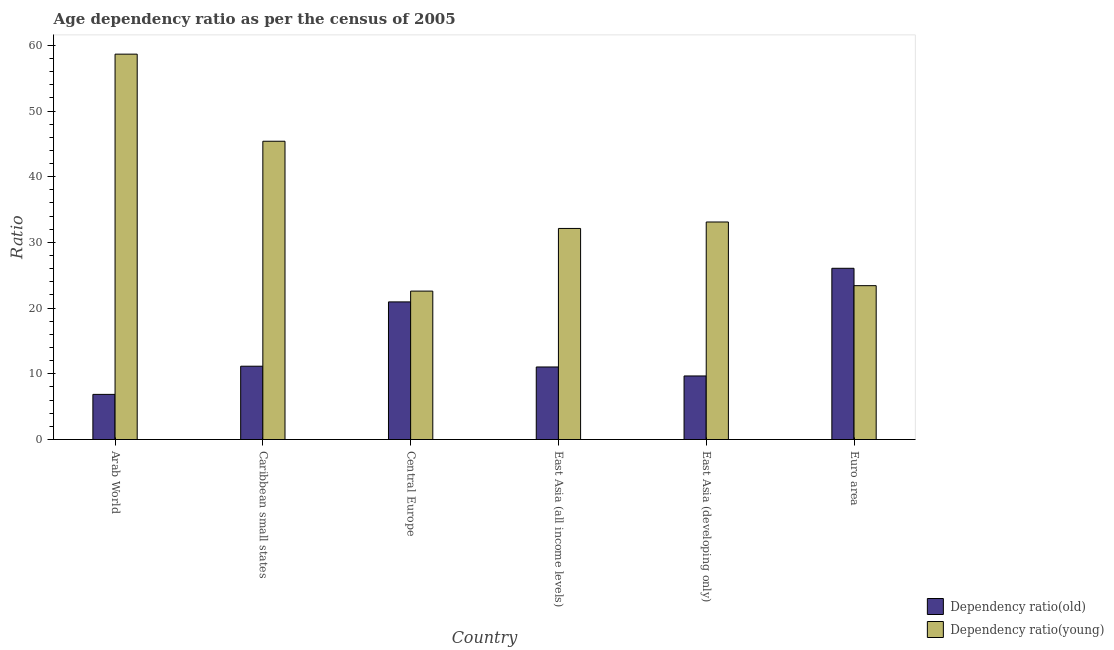Are the number of bars per tick equal to the number of legend labels?
Provide a succinct answer. Yes. How many bars are there on the 5th tick from the right?
Your answer should be compact. 2. What is the label of the 1st group of bars from the left?
Your answer should be compact. Arab World. In how many cases, is the number of bars for a given country not equal to the number of legend labels?
Make the answer very short. 0. What is the age dependency ratio(old) in Arab World?
Ensure brevity in your answer.  6.87. Across all countries, what is the maximum age dependency ratio(old)?
Your response must be concise. 26.06. Across all countries, what is the minimum age dependency ratio(old)?
Make the answer very short. 6.87. In which country was the age dependency ratio(young) maximum?
Offer a very short reply. Arab World. In which country was the age dependency ratio(young) minimum?
Your answer should be very brief. Central Europe. What is the total age dependency ratio(young) in the graph?
Your answer should be compact. 215.29. What is the difference between the age dependency ratio(old) in Caribbean small states and that in East Asia (developing only)?
Ensure brevity in your answer.  1.48. What is the difference between the age dependency ratio(old) in Euro area and the age dependency ratio(young) in Arab World?
Offer a terse response. -32.59. What is the average age dependency ratio(young) per country?
Offer a terse response. 35.88. What is the difference between the age dependency ratio(old) and age dependency ratio(young) in East Asia (developing only)?
Make the answer very short. -23.43. In how many countries, is the age dependency ratio(old) greater than 38 ?
Provide a succinct answer. 0. What is the ratio of the age dependency ratio(old) in Central Europe to that in East Asia (all income levels)?
Make the answer very short. 1.9. Is the age dependency ratio(young) in Caribbean small states less than that in East Asia (developing only)?
Offer a terse response. No. Is the difference between the age dependency ratio(young) in Arab World and Caribbean small states greater than the difference between the age dependency ratio(old) in Arab World and Caribbean small states?
Provide a succinct answer. Yes. What is the difference between the highest and the second highest age dependency ratio(old)?
Provide a short and direct response. 5.12. What is the difference between the highest and the lowest age dependency ratio(old)?
Your answer should be compact. 19.19. In how many countries, is the age dependency ratio(young) greater than the average age dependency ratio(young) taken over all countries?
Provide a succinct answer. 2. Is the sum of the age dependency ratio(young) in Central Europe and East Asia (developing only) greater than the maximum age dependency ratio(old) across all countries?
Offer a terse response. Yes. What does the 2nd bar from the left in East Asia (developing only) represents?
Offer a very short reply. Dependency ratio(young). What does the 2nd bar from the right in East Asia (developing only) represents?
Keep it short and to the point. Dependency ratio(old). Are the values on the major ticks of Y-axis written in scientific E-notation?
Give a very brief answer. No. Does the graph contain grids?
Give a very brief answer. No. Where does the legend appear in the graph?
Offer a very short reply. Bottom right. What is the title of the graph?
Offer a very short reply. Age dependency ratio as per the census of 2005. What is the label or title of the X-axis?
Ensure brevity in your answer.  Country. What is the label or title of the Y-axis?
Keep it short and to the point. Ratio. What is the Ratio of Dependency ratio(old) in Arab World?
Make the answer very short. 6.87. What is the Ratio in Dependency ratio(young) in Arab World?
Your answer should be very brief. 58.66. What is the Ratio in Dependency ratio(old) in Caribbean small states?
Provide a succinct answer. 11.16. What is the Ratio of Dependency ratio(young) in Caribbean small states?
Your answer should be compact. 45.4. What is the Ratio in Dependency ratio(old) in Central Europe?
Offer a very short reply. 20.95. What is the Ratio of Dependency ratio(young) in Central Europe?
Give a very brief answer. 22.59. What is the Ratio in Dependency ratio(old) in East Asia (all income levels)?
Offer a very short reply. 11.04. What is the Ratio in Dependency ratio(young) in East Asia (all income levels)?
Keep it short and to the point. 32.13. What is the Ratio in Dependency ratio(old) in East Asia (developing only)?
Keep it short and to the point. 9.67. What is the Ratio of Dependency ratio(young) in East Asia (developing only)?
Make the answer very short. 33.11. What is the Ratio of Dependency ratio(old) in Euro area?
Your answer should be very brief. 26.06. What is the Ratio of Dependency ratio(young) in Euro area?
Keep it short and to the point. 23.42. Across all countries, what is the maximum Ratio in Dependency ratio(old)?
Your answer should be compact. 26.06. Across all countries, what is the maximum Ratio of Dependency ratio(young)?
Offer a very short reply. 58.66. Across all countries, what is the minimum Ratio in Dependency ratio(old)?
Your answer should be compact. 6.87. Across all countries, what is the minimum Ratio in Dependency ratio(young)?
Offer a terse response. 22.59. What is the total Ratio of Dependency ratio(old) in the graph?
Keep it short and to the point. 85.75. What is the total Ratio in Dependency ratio(young) in the graph?
Your answer should be very brief. 215.29. What is the difference between the Ratio in Dependency ratio(old) in Arab World and that in Caribbean small states?
Your answer should be very brief. -4.29. What is the difference between the Ratio of Dependency ratio(young) in Arab World and that in Caribbean small states?
Provide a succinct answer. 13.26. What is the difference between the Ratio in Dependency ratio(old) in Arab World and that in Central Europe?
Offer a very short reply. -14.08. What is the difference between the Ratio in Dependency ratio(young) in Arab World and that in Central Europe?
Provide a succinct answer. 36.07. What is the difference between the Ratio of Dependency ratio(old) in Arab World and that in East Asia (all income levels)?
Give a very brief answer. -4.17. What is the difference between the Ratio of Dependency ratio(young) in Arab World and that in East Asia (all income levels)?
Offer a terse response. 26.53. What is the difference between the Ratio in Dependency ratio(old) in Arab World and that in East Asia (developing only)?
Ensure brevity in your answer.  -2.81. What is the difference between the Ratio in Dependency ratio(young) in Arab World and that in East Asia (developing only)?
Provide a short and direct response. 25.55. What is the difference between the Ratio of Dependency ratio(old) in Arab World and that in Euro area?
Your answer should be compact. -19.19. What is the difference between the Ratio in Dependency ratio(young) in Arab World and that in Euro area?
Your answer should be very brief. 35.24. What is the difference between the Ratio in Dependency ratio(old) in Caribbean small states and that in Central Europe?
Provide a short and direct response. -9.79. What is the difference between the Ratio of Dependency ratio(young) in Caribbean small states and that in Central Europe?
Make the answer very short. 22.81. What is the difference between the Ratio of Dependency ratio(old) in Caribbean small states and that in East Asia (all income levels)?
Provide a short and direct response. 0.12. What is the difference between the Ratio in Dependency ratio(young) in Caribbean small states and that in East Asia (all income levels)?
Ensure brevity in your answer.  13.27. What is the difference between the Ratio of Dependency ratio(old) in Caribbean small states and that in East Asia (developing only)?
Provide a succinct answer. 1.48. What is the difference between the Ratio of Dependency ratio(young) in Caribbean small states and that in East Asia (developing only)?
Your answer should be very brief. 12.29. What is the difference between the Ratio of Dependency ratio(old) in Caribbean small states and that in Euro area?
Give a very brief answer. -14.9. What is the difference between the Ratio in Dependency ratio(young) in Caribbean small states and that in Euro area?
Your answer should be compact. 21.98. What is the difference between the Ratio of Dependency ratio(old) in Central Europe and that in East Asia (all income levels)?
Give a very brief answer. 9.9. What is the difference between the Ratio in Dependency ratio(young) in Central Europe and that in East Asia (all income levels)?
Offer a very short reply. -9.54. What is the difference between the Ratio of Dependency ratio(old) in Central Europe and that in East Asia (developing only)?
Your response must be concise. 11.27. What is the difference between the Ratio in Dependency ratio(young) in Central Europe and that in East Asia (developing only)?
Make the answer very short. -10.52. What is the difference between the Ratio in Dependency ratio(old) in Central Europe and that in Euro area?
Your answer should be very brief. -5.12. What is the difference between the Ratio of Dependency ratio(young) in Central Europe and that in Euro area?
Provide a succinct answer. -0.83. What is the difference between the Ratio in Dependency ratio(old) in East Asia (all income levels) and that in East Asia (developing only)?
Offer a terse response. 1.37. What is the difference between the Ratio of Dependency ratio(young) in East Asia (all income levels) and that in East Asia (developing only)?
Your answer should be compact. -0.98. What is the difference between the Ratio of Dependency ratio(old) in East Asia (all income levels) and that in Euro area?
Your answer should be compact. -15.02. What is the difference between the Ratio of Dependency ratio(young) in East Asia (all income levels) and that in Euro area?
Your answer should be compact. 8.71. What is the difference between the Ratio of Dependency ratio(old) in East Asia (developing only) and that in Euro area?
Offer a very short reply. -16.39. What is the difference between the Ratio of Dependency ratio(young) in East Asia (developing only) and that in Euro area?
Give a very brief answer. 9.69. What is the difference between the Ratio of Dependency ratio(old) in Arab World and the Ratio of Dependency ratio(young) in Caribbean small states?
Offer a very short reply. -38.53. What is the difference between the Ratio of Dependency ratio(old) in Arab World and the Ratio of Dependency ratio(young) in Central Europe?
Provide a short and direct response. -15.72. What is the difference between the Ratio of Dependency ratio(old) in Arab World and the Ratio of Dependency ratio(young) in East Asia (all income levels)?
Offer a very short reply. -25.26. What is the difference between the Ratio of Dependency ratio(old) in Arab World and the Ratio of Dependency ratio(young) in East Asia (developing only)?
Ensure brevity in your answer.  -26.24. What is the difference between the Ratio of Dependency ratio(old) in Arab World and the Ratio of Dependency ratio(young) in Euro area?
Provide a succinct answer. -16.55. What is the difference between the Ratio in Dependency ratio(old) in Caribbean small states and the Ratio in Dependency ratio(young) in Central Europe?
Provide a succinct answer. -11.43. What is the difference between the Ratio of Dependency ratio(old) in Caribbean small states and the Ratio of Dependency ratio(young) in East Asia (all income levels)?
Ensure brevity in your answer.  -20.97. What is the difference between the Ratio in Dependency ratio(old) in Caribbean small states and the Ratio in Dependency ratio(young) in East Asia (developing only)?
Your response must be concise. -21.95. What is the difference between the Ratio of Dependency ratio(old) in Caribbean small states and the Ratio of Dependency ratio(young) in Euro area?
Give a very brief answer. -12.26. What is the difference between the Ratio in Dependency ratio(old) in Central Europe and the Ratio in Dependency ratio(young) in East Asia (all income levels)?
Offer a terse response. -11.18. What is the difference between the Ratio in Dependency ratio(old) in Central Europe and the Ratio in Dependency ratio(young) in East Asia (developing only)?
Offer a terse response. -12.16. What is the difference between the Ratio in Dependency ratio(old) in Central Europe and the Ratio in Dependency ratio(young) in Euro area?
Offer a terse response. -2.47. What is the difference between the Ratio in Dependency ratio(old) in East Asia (all income levels) and the Ratio in Dependency ratio(young) in East Asia (developing only)?
Provide a short and direct response. -22.07. What is the difference between the Ratio of Dependency ratio(old) in East Asia (all income levels) and the Ratio of Dependency ratio(young) in Euro area?
Your answer should be very brief. -12.37. What is the difference between the Ratio in Dependency ratio(old) in East Asia (developing only) and the Ratio in Dependency ratio(young) in Euro area?
Provide a short and direct response. -13.74. What is the average Ratio of Dependency ratio(old) per country?
Ensure brevity in your answer.  14.29. What is the average Ratio in Dependency ratio(young) per country?
Ensure brevity in your answer.  35.88. What is the difference between the Ratio of Dependency ratio(old) and Ratio of Dependency ratio(young) in Arab World?
Your answer should be compact. -51.79. What is the difference between the Ratio in Dependency ratio(old) and Ratio in Dependency ratio(young) in Caribbean small states?
Your answer should be compact. -34.24. What is the difference between the Ratio in Dependency ratio(old) and Ratio in Dependency ratio(young) in Central Europe?
Keep it short and to the point. -1.64. What is the difference between the Ratio in Dependency ratio(old) and Ratio in Dependency ratio(young) in East Asia (all income levels)?
Your response must be concise. -21.08. What is the difference between the Ratio of Dependency ratio(old) and Ratio of Dependency ratio(young) in East Asia (developing only)?
Your answer should be compact. -23.43. What is the difference between the Ratio of Dependency ratio(old) and Ratio of Dependency ratio(young) in Euro area?
Ensure brevity in your answer.  2.65. What is the ratio of the Ratio in Dependency ratio(old) in Arab World to that in Caribbean small states?
Keep it short and to the point. 0.62. What is the ratio of the Ratio in Dependency ratio(young) in Arab World to that in Caribbean small states?
Offer a very short reply. 1.29. What is the ratio of the Ratio in Dependency ratio(old) in Arab World to that in Central Europe?
Your response must be concise. 0.33. What is the ratio of the Ratio in Dependency ratio(young) in Arab World to that in Central Europe?
Provide a short and direct response. 2.6. What is the ratio of the Ratio in Dependency ratio(old) in Arab World to that in East Asia (all income levels)?
Ensure brevity in your answer.  0.62. What is the ratio of the Ratio of Dependency ratio(young) in Arab World to that in East Asia (all income levels)?
Offer a very short reply. 1.83. What is the ratio of the Ratio of Dependency ratio(old) in Arab World to that in East Asia (developing only)?
Give a very brief answer. 0.71. What is the ratio of the Ratio of Dependency ratio(young) in Arab World to that in East Asia (developing only)?
Your answer should be very brief. 1.77. What is the ratio of the Ratio in Dependency ratio(old) in Arab World to that in Euro area?
Make the answer very short. 0.26. What is the ratio of the Ratio in Dependency ratio(young) in Arab World to that in Euro area?
Provide a succinct answer. 2.5. What is the ratio of the Ratio in Dependency ratio(old) in Caribbean small states to that in Central Europe?
Your answer should be very brief. 0.53. What is the ratio of the Ratio in Dependency ratio(young) in Caribbean small states to that in Central Europe?
Ensure brevity in your answer.  2.01. What is the ratio of the Ratio in Dependency ratio(old) in Caribbean small states to that in East Asia (all income levels)?
Keep it short and to the point. 1.01. What is the ratio of the Ratio in Dependency ratio(young) in Caribbean small states to that in East Asia (all income levels)?
Your response must be concise. 1.41. What is the ratio of the Ratio in Dependency ratio(old) in Caribbean small states to that in East Asia (developing only)?
Ensure brevity in your answer.  1.15. What is the ratio of the Ratio in Dependency ratio(young) in Caribbean small states to that in East Asia (developing only)?
Offer a terse response. 1.37. What is the ratio of the Ratio of Dependency ratio(old) in Caribbean small states to that in Euro area?
Offer a very short reply. 0.43. What is the ratio of the Ratio in Dependency ratio(young) in Caribbean small states to that in Euro area?
Offer a terse response. 1.94. What is the ratio of the Ratio in Dependency ratio(old) in Central Europe to that in East Asia (all income levels)?
Ensure brevity in your answer.  1.9. What is the ratio of the Ratio in Dependency ratio(young) in Central Europe to that in East Asia (all income levels)?
Provide a succinct answer. 0.7. What is the ratio of the Ratio of Dependency ratio(old) in Central Europe to that in East Asia (developing only)?
Make the answer very short. 2.17. What is the ratio of the Ratio in Dependency ratio(young) in Central Europe to that in East Asia (developing only)?
Offer a terse response. 0.68. What is the ratio of the Ratio of Dependency ratio(old) in Central Europe to that in Euro area?
Your answer should be very brief. 0.8. What is the ratio of the Ratio of Dependency ratio(young) in Central Europe to that in Euro area?
Ensure brevity in your answer.  0.96. What is the ratio of the Ratio of Dependency ratio(old) in East Asia (all income levels) to that in East Asia (developing only)?
Your answer should be very brief. 1.14. What is the ratio of the Ratio of Dependency ratio(young) in East Asia (all income levels) to that in East Asia (developing only)?
Offer a very short reply. 0.97. What is the ratio of the Ratio in Dependency ratio(old) in East Asia (all income levels) to that in Euro area?
Ensure brevity in your answer.  0.42. What is the ratio of the Ratio in Dependency ratio(young) in East Asia (all income levels) to that in Euro area?
Offer a terse response. 1.37. What is the ratio of the Ratio in Dependency ratio(old) in East Asia (developing only) to that in Euro area?
Give a very brief answer. 0.37. What is the ratio of the Ratio of Dependency ratio(young) in East Asia (developing only) to that in Euro area?
Ensure brevity in your answer.  1.41. What is the difference between the highest and the second highest Ratio of Dependency ratio(old)?
Offer a terse response. 5.12. What is the difference between the highest and the second highest Ratio of Dependency ratio(young)?
Your response must be concise. 13.26. What is the difference between the highest and the lowest Ratio of Dependency ratio(old)?
Your response must be concise. 19.19. What is the difference between the highest and the lowest Ratio of Dependency ratio(young)?
Ensure brevity in your answer.  36.07. 